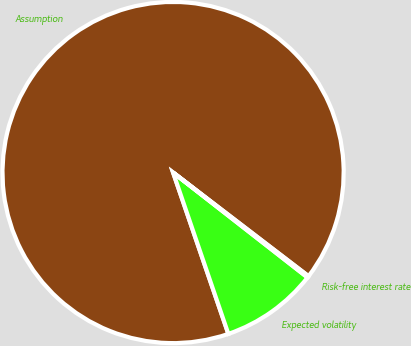<chart> <loc_0><loc_0><loc_500><loc_500><pie_chart><fcel>Assumption<fcel>Expected volatility<fcel>Risk-free interest rate<nl><fcel>90.64%<fcel>9.2%<fcel>0.15%<nl></chart> 